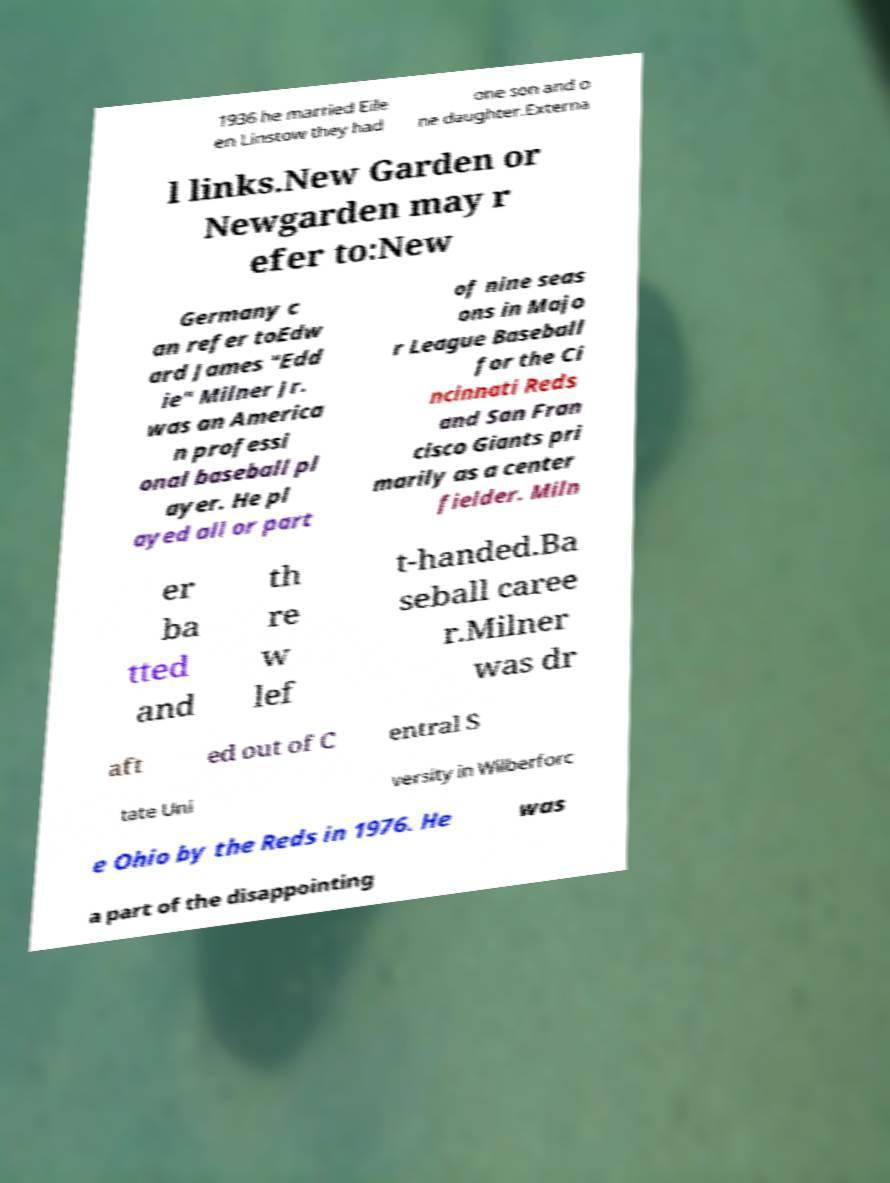Could you assist in decoding the text presented in this image and type it out clearly? 1936 he married Eile en Linstow they had one son and o ne daughter.Externa l links.New Garden or Newgarden may r efer to:New Germany c an refer toEdw ard James "Edd ie" Milner Jr. was an America n professi onal baseball pl ayer. He pl ayed all or part of nine seas ons in Majo r League Baseball for the Ci ncinnati Reds and San Fran cisco Giants pri marily as a center fielder. Miln er ba tted and th re w lef t-handed.Ba seball caree r.Milner was dr aft ed out of C entral S tate Uni versity in Wilberforc e Ohio by the Reds in 1976. He was a part of the disappointing 